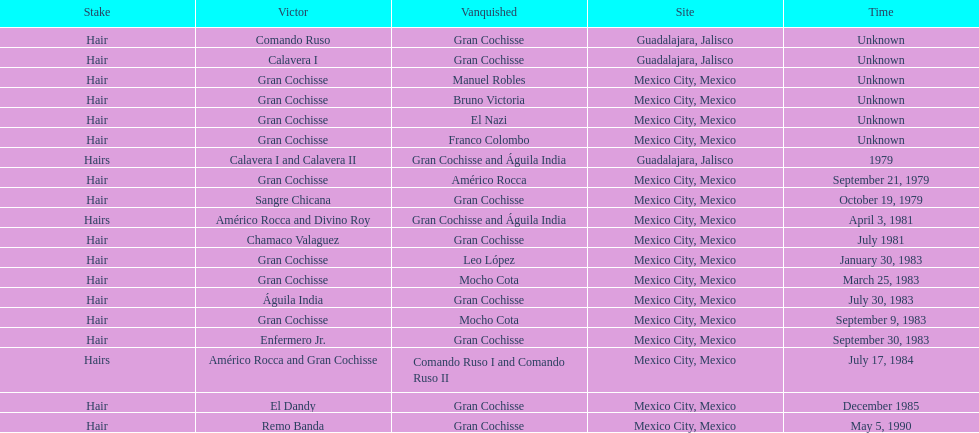When did bruno victoria experience his first loss in a game? Unknown. 